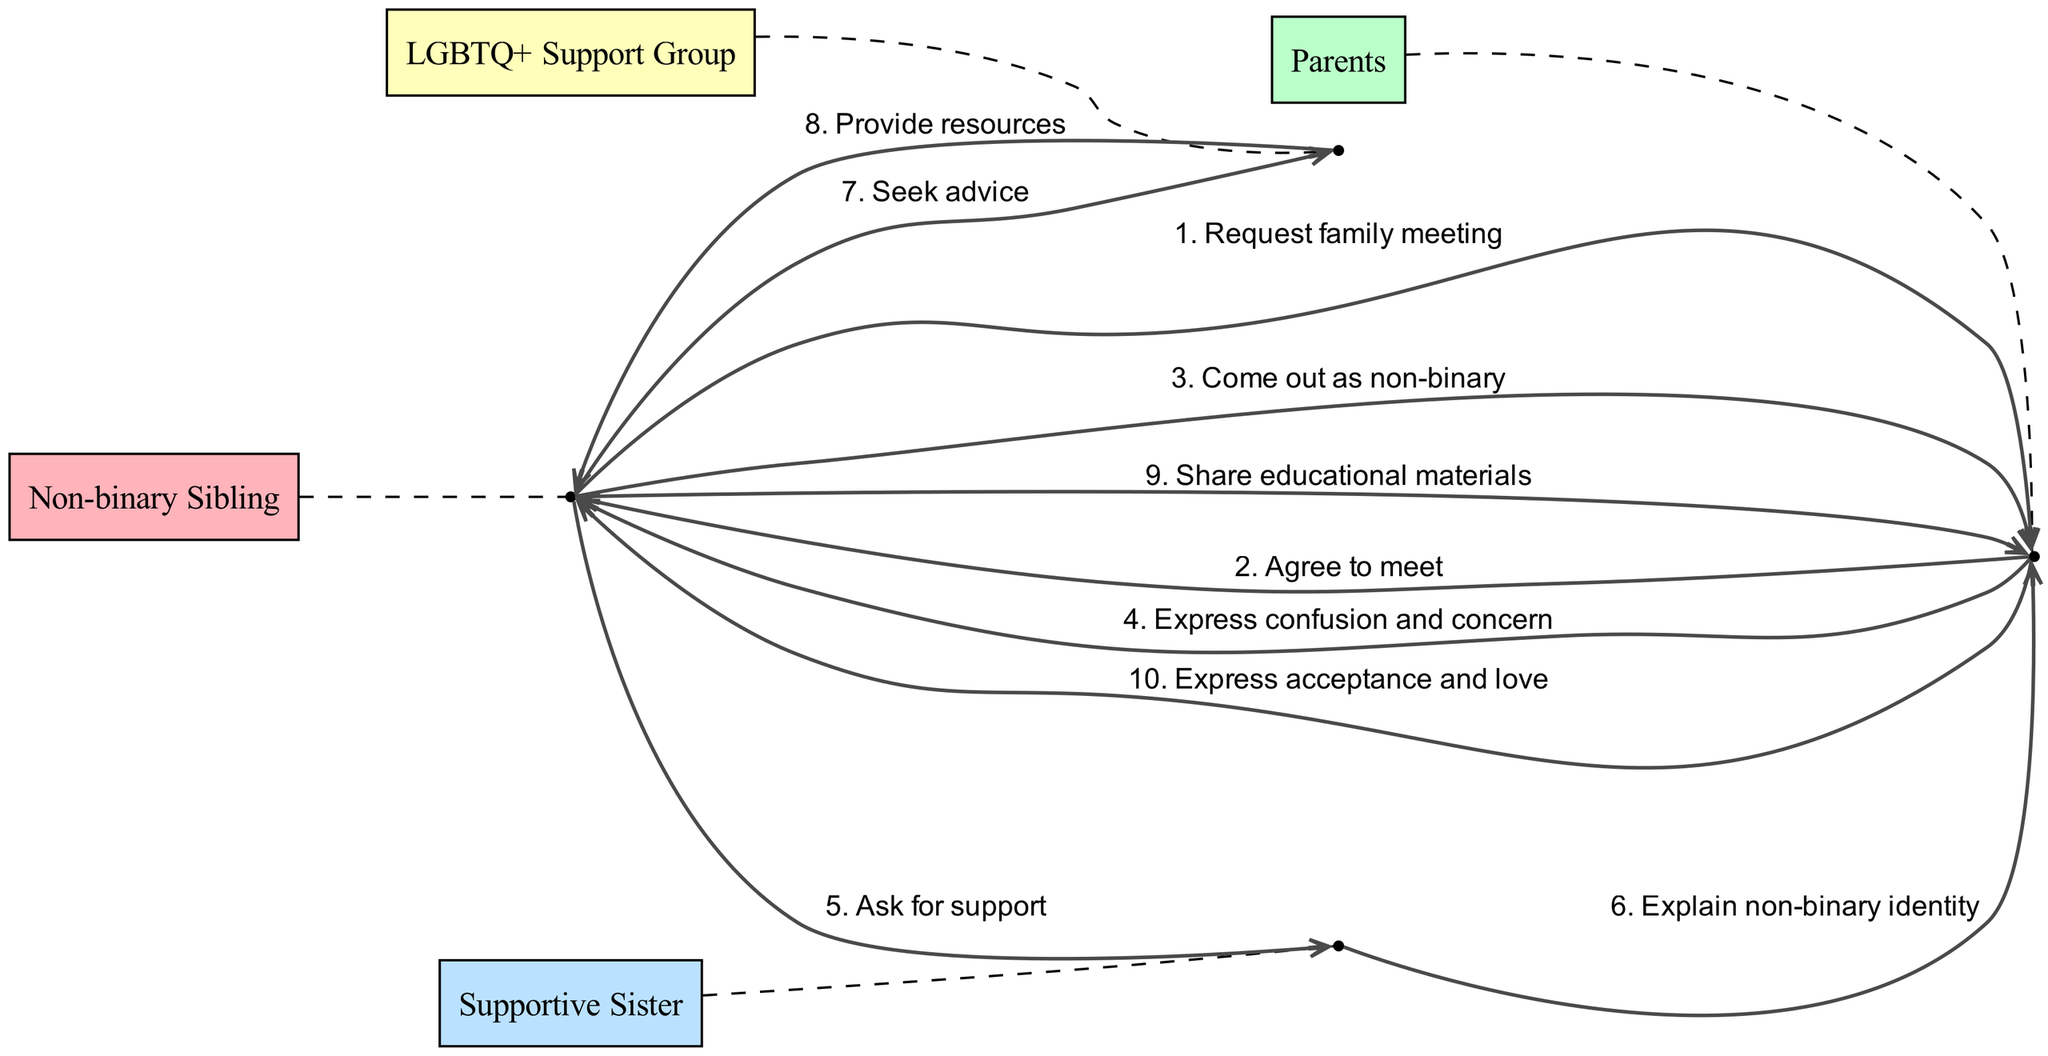What actors are involved in the sequence? The sequence involves four actors: Non-binary Sibling, Parents, Supportive Sister, and LGBTQ+ Support Group. This information can be gathered by examining the "actors" section of the data.
Answer: Non-binary Sibling, Parents, Supportive Sister, LGBTQ+ Support Group How many messages are exchanged in total? The total number of messages exchanged is obtained by counting the elements listed in the "sequence" section, which shows 10 distinct interactions.
Answer: 10 Who does the Non-binary Sibling seek advice from? The Non-binary Sibling specifically reaches out to the LGBTQ+ Support Group for advice, as indicated by the message in the sequence where they directly communicate with this particular group.
Answer: LGBTQ+ Support Group What is the last message exchanged in the sequence? The last message in the sequence is exchanged from the Parents to the Non-binary Sibling, where they express acceptance and love. This is the final interaction listed in the sequence data.
Answer: Express acceptance and love What is the reaction of the Parents after the Non-binary Sibling comes out? Following the Non-binary Sibling’s disclosure of their non-binary identity, the Parents express confusion and concern, as detailed in the sequence message that follows the coming out step.
Answer: Express confusion and concern Which actor explains the non-binary identity to the Parents? The Supportive Sister is the one who explains the non-binary identity to the Parents, as shown in the sequence where they communicate directly to the Parents following the Non-binary Sibling's coming out.
Answer: Supportive Sister What does the Non-binary Sibling share with the Parents after seeking resources? After seeking advice and receiving resources, the Non-binary Sibling shares educational materials with the Parents, which is explicitly mentioned in the sequence where they interact with their family.
Answer: Share educational materials When do the Parents agree to meet the Non-binary Sibling? The Parents agree to meet the Non-binary Sibling immediately after they request a family meeting, which is the second message exchanged in the sequence.
Answer: Agree to meet What role does the LGBTQ+ Support Group play in the sequence? The LGBTQ+ Support Group plays a supportive role by providing resources to the Non-binary Sibling when they seek advice, emphasizing the educational support aspect of the coming-out process.
Answer: Provide resources 